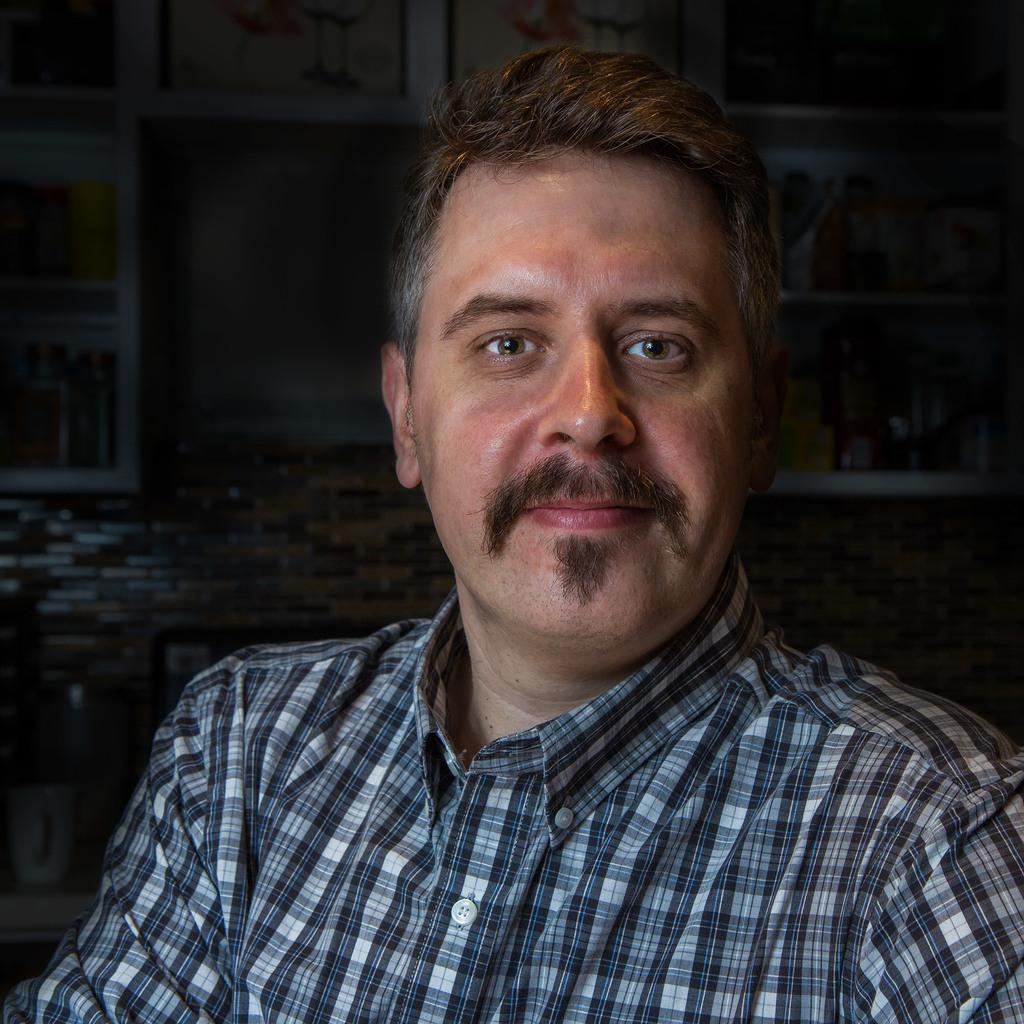What is the main subject of the image? There is a person in the image. What is the person doing in the image? The person is smiling. What can be observed about the background of the image? The background of the image is dark. What type of quill is the person holding in the image? There is no quill present in the image. Is the person wearing a mask in the image? No, the person is not wearing a mask in the image. 